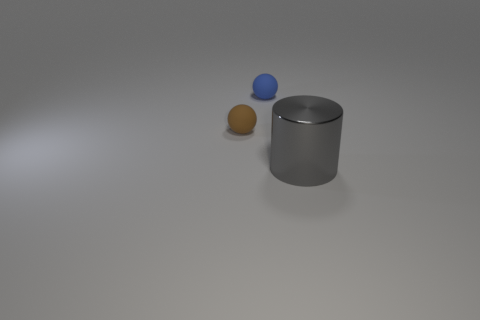Add 2 big green things. How many objects exist? 5 Subtract all cylinders. How many objects are left? 2 Add 1 large metallic cylinders. How many large metallic cylinders are left? 2 Add 3 cylinders. How many cylinders exist? 4 Subtract 0 green cubes. How many objects are left? 3 Subtract all big metallic cylinders. Subtract all blue balls. How many objects are left? 1 